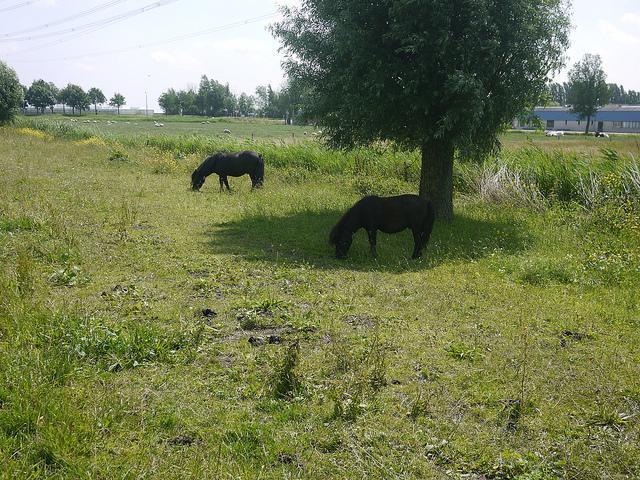How many animals under the tree?
Give a very brief answer. 2. How many people are in the photo?
Give a very brief answer. 0. 